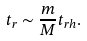Convert formula to latex. <formula><loc_0><loc_0><loc_500><loc_500>t _ { r } \sim \frac { m } { M } t _ { r h } .</formula> 